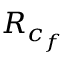<formula> <loc_0><loc_0><loc_500><loc_500>R _ { c _ { f } }</formula> 